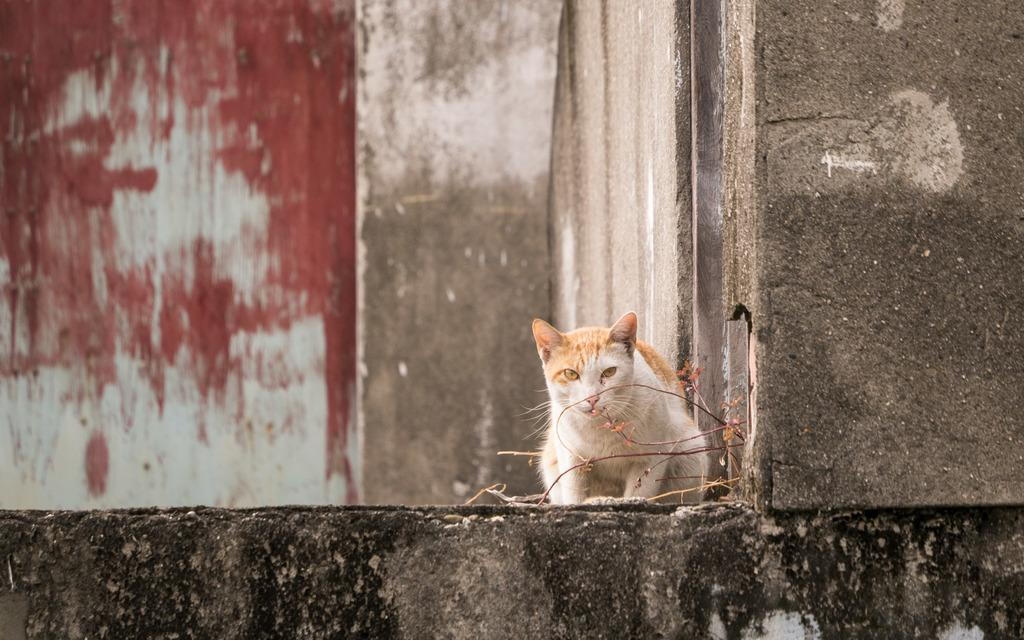What can be seen on the right side of the image? There are stems on the right side of the image. What type of animal is present in the image? There is a cream and white color cat in the image. Where is the cat located in relation to the stems? The cat is near the stems. What color paint is on the wall in the background of the image? There is red paint on the wall in the background of the image. What type of account is the cat managing in the image? There is no mention of an account in the image; it features a cat near stems with red paint on the wall in the background. Is there a hospital visible in the image? No, there is no hospital present in the image. 